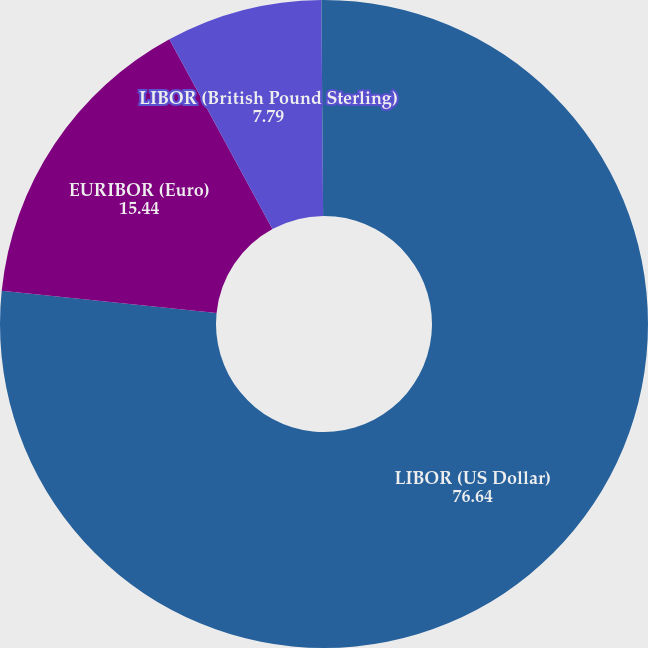Convert chart. <chart><loc_0><loc_0><loc_500><loc_500><pie_chart><fcel>LIBOR (US Dollar)<fcel>EURIBOR (Euro)<fcel>LIBOR (British Pound Sterling)<fcel>Chilean Unidad de Fomento<nl><fcel>76.64%<fcel>15.44%<fcel>7.79%<fcel>0.13%<nl></chart> 